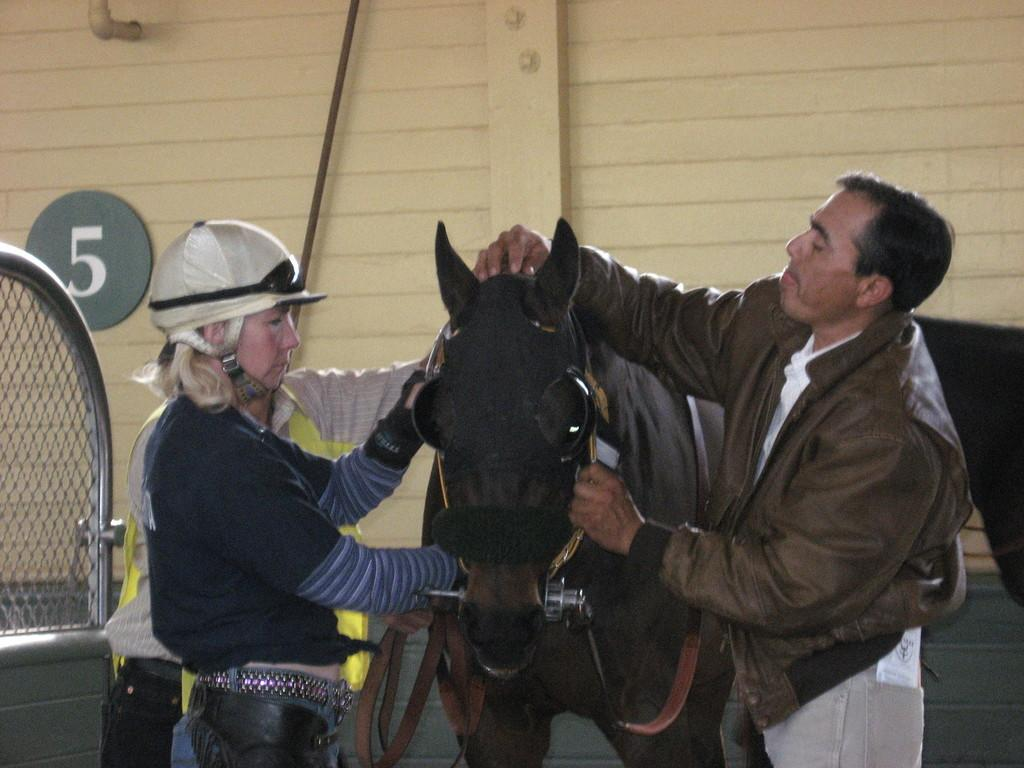Who or what can be seen in the front of the image? There are people in the front of the image. What type of barrier is present in the image? There is a fence in the image. What animal is featured in the image? There is a black color horse in the image. What type of structure is visible in the image? There is a wall in the image. What object can be seen that is typically used for transporting fluids? There is a pipe in the image. What type of scent can be detected from the horse in the image? There is no information about the scent of the horse in the image. Is there a soap dispenser visible in the image? There is no soap dispenser present in the image. Can you see a plane flying in the sky in the image? There is no plane visible in the image. 